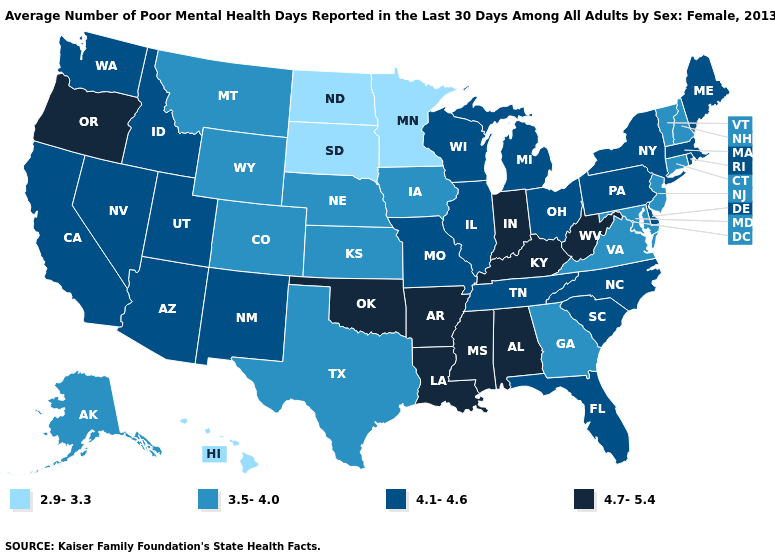What is the value of New York?
Give a very brief answer. 4.1-4.6. Which states have the lowest value in the MidWest?
Give a very brief answer. Minnesota, North Dakota, South Dakota. What is the value of Virginia?
Quick response, please. 3.5-4.0. Among the states that border Delaware , does Pennsylvania have the highest value?
Be succinct. Yes. Name the states that have a value in the range 4.1-4.6?
Give a very brief answer. Arizona, California, Delaware, Florida, Idaho, Illinois, Maine, Massachusetts, Michigan, Missouri, Nevada, New Mexico, New York, North Carolina, Ohio, Pennsylvania, Rhode Island, South Carolina, Tennessee, Utah, Washington, Wisconsin. How many symbols are there in the legend?
Concise answer only. 4. What is the highest value in states that border Texas?
Keep it brief. 4.7-5.4. Does Rhode Island have the highest value in the Northeast?
Answer briefly. Yes. What is the lowest value in states that border Tennessee?
Concise answer only. 3.5-4.0. What is the highest value in states that border New Mexico?
Short answer required. 4.7-5.4. Among the states that border Maryland , does Delaware have the highest value?
Short answer required. No. Among the states that border Maryland , does Pennsylvania have the highest value?
Answer briefly. No. What is the lowest value in the West?
Quick response, please. 2.9-3.3. Name the states that have a value in the range 2.9-3.3?
Concise answer only. Hawaii, Minnesota, North Dakota, South Dakota. Does Mississippi have the same value as Oklahoma?
Write a very short answer. Yes. 